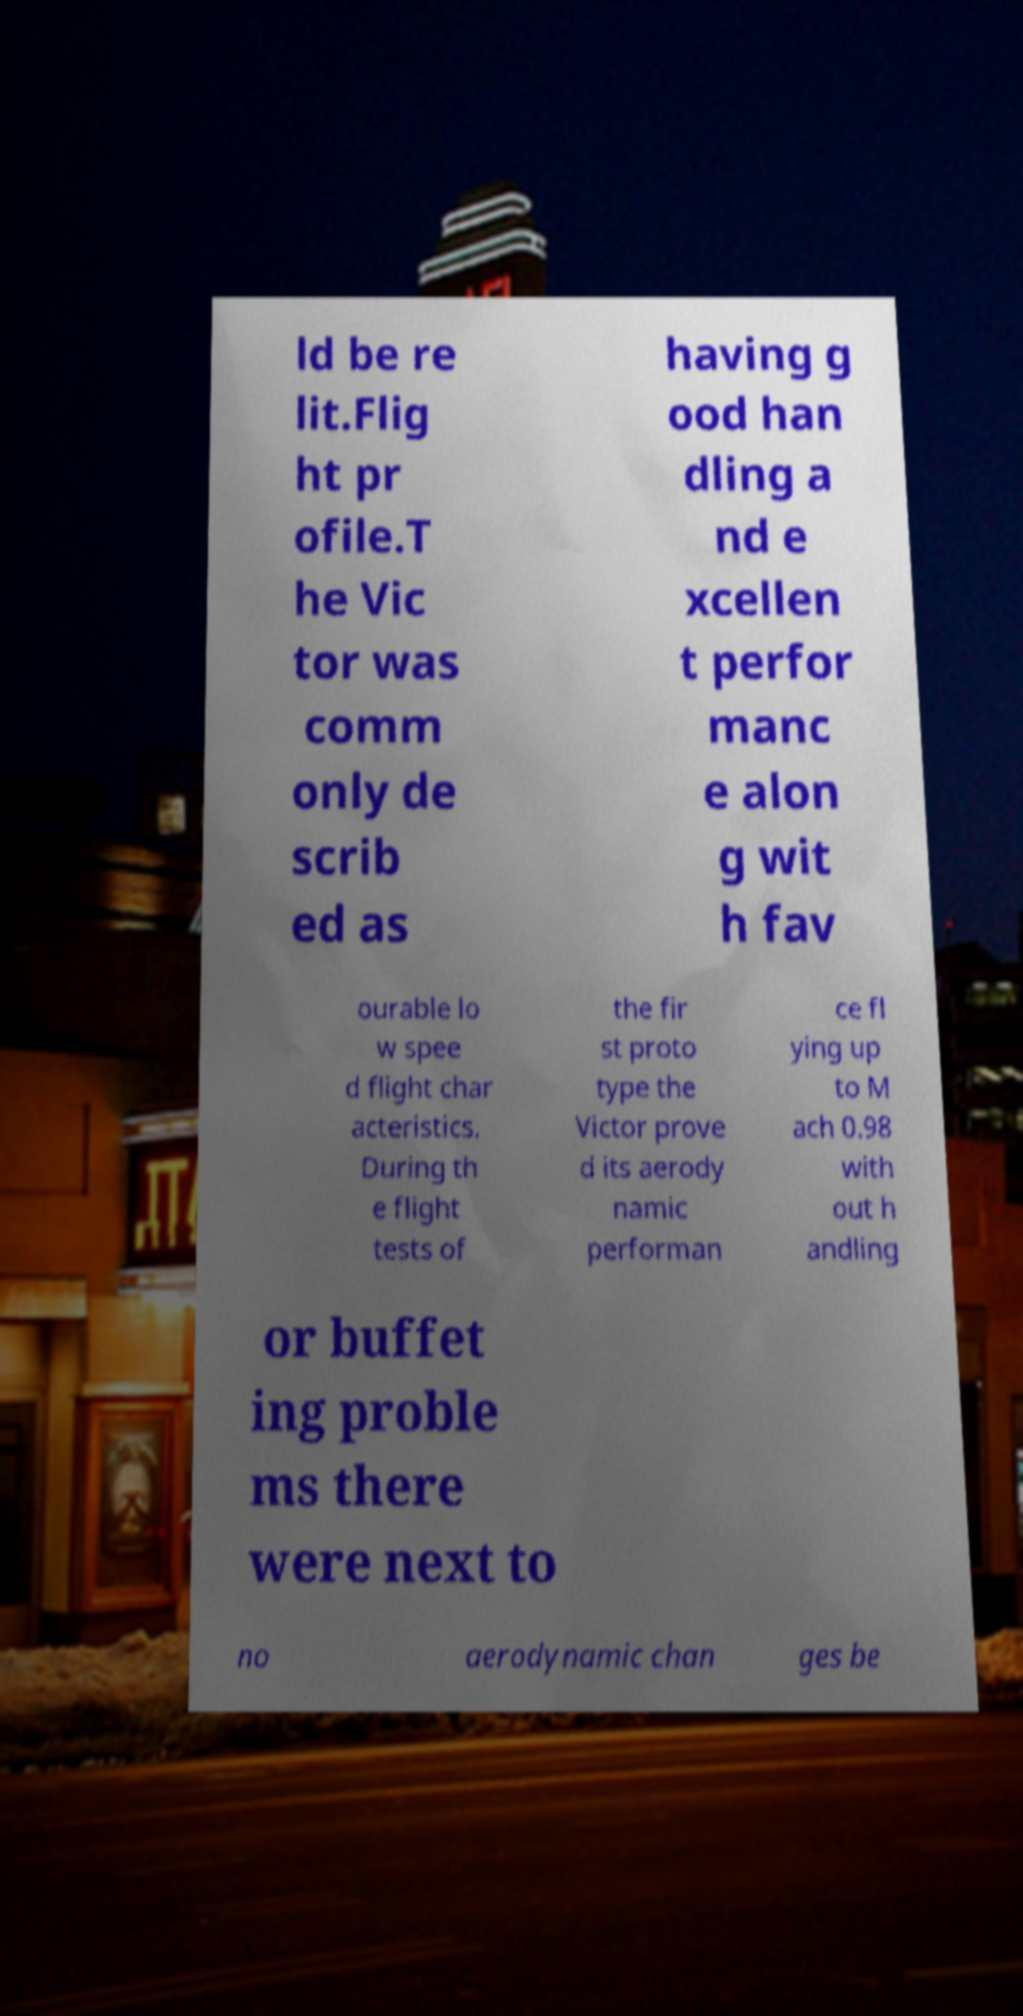Could you assist in decoding the text presented in this image and type it out clearly? ld be re lit.Flig ht pr ofile.T he Vic tor was comm only de scrib ed as having g ood han dling a nd e xcellen t perfor manc e alon g wit h fav ourable lo w spee d flight char acteristics. During th e flight tests of the fir st proto type the Victor prove d its aerody namic performan ce fl ying up to M ach 0.98 with out h andling or buffet ing proble ms there were next to no aerodynamic chan ges be 